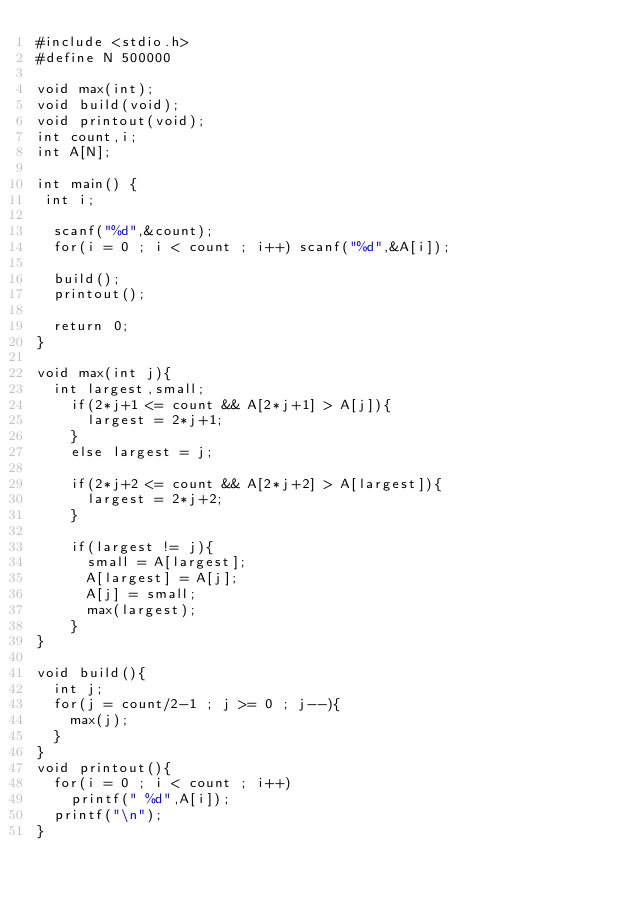<code> <loc_0><loc_0><loc_500><loc_500><_C_>#include <stdio.h>
#define N 500000

void max(int);
void build(void);
void printout(void);
int count,i;
int A[N];

int main() {
 int i;
 
  scanf("%d",&count);
  for(i = 0 ; i < count ; i++) scanf("%d",&A[i]);
  
  build();
  printout();

  return 0;
}

void max(int j){
  int largest,small;    
    if(2*j+1 <= count && A[2*j+1] > A[j]){
      largest = 2*j+1;
    }
    else largest = j;
  
    if(2*j+2 <= count && A[2*j+2] > A[largest]){
      largest = 2*j+2;
    }

    if(largest != j){
      small = A[largest];
      A[largest] = A[j];
      A[j] = small;
      max(largest);
    }
}

void build(){
  int j;
  for(j = count/2-1 ; j >= 0 ; j--){
    max(j);  
  }
}
void printout(){
  for(i = 0 ; i < count ; i++)
    printf(" %d",A[i]);
  printf("\n");
}</code> 